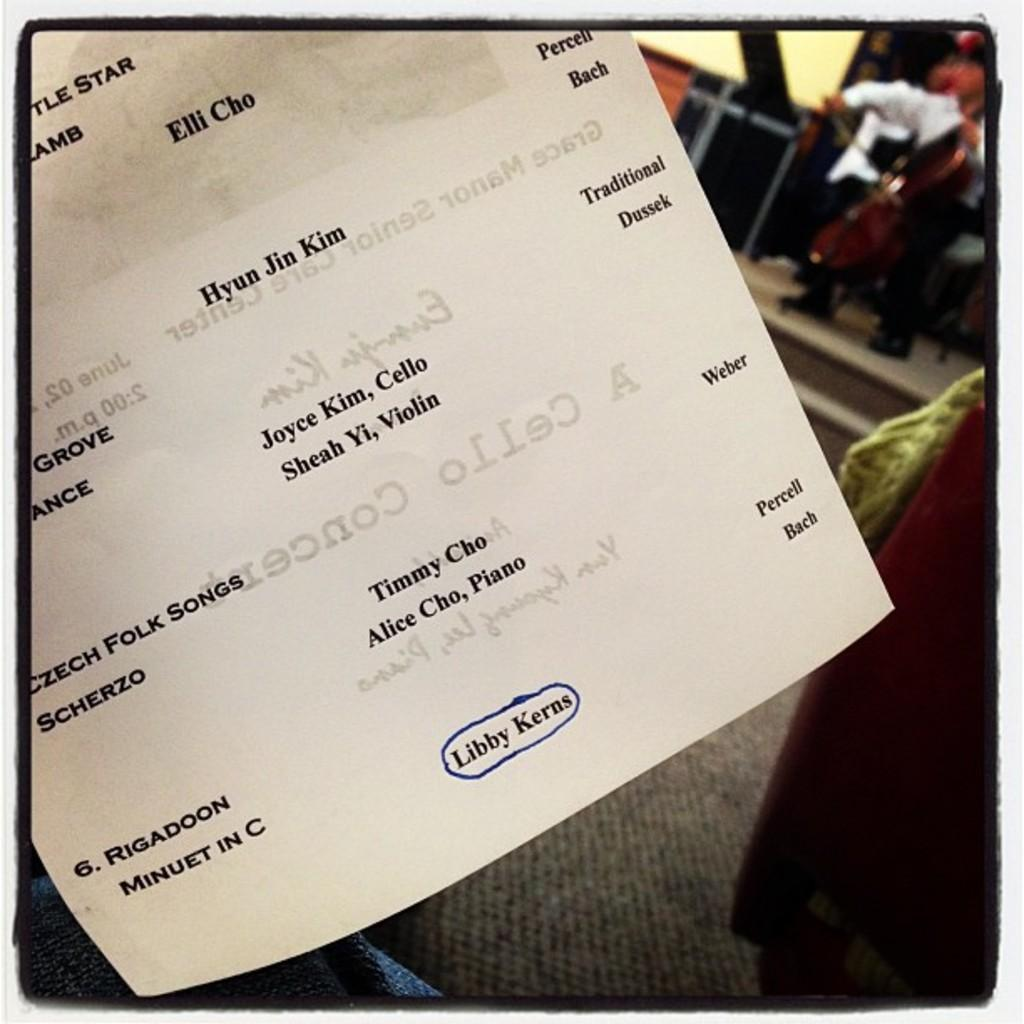What is on the paper that is visible in the image? There is a paper with notes in the image. What type of furniture can be seen in the background of the image? There is a couch in the background of the image. What is the person in the image doing? The person is playing a musical instrument on a stage in the image. What type of rail can be seen in the image? There is no rail present in the image. What nation is the person on stage representing in the image? The image does not provide information about the person's nationality or any representation of a nation. 